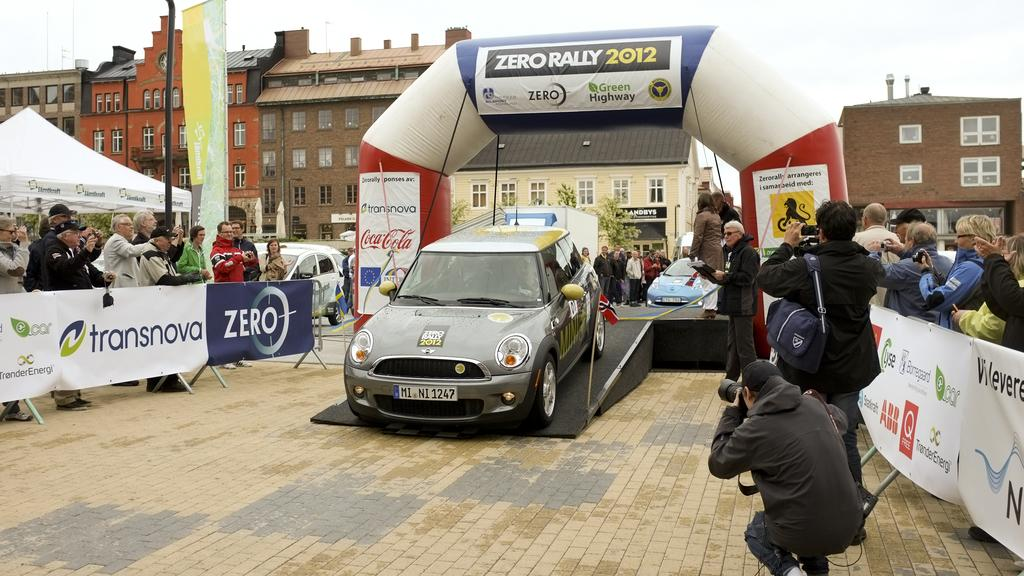What types of vehicles can be seen in the image? There are cars in the image. Can you describe the people in the image? There are people in the image. What kind of signage is present in the image? There are banners and hoardings in the image. What type of temporary shelter is visible in the image? There is a tent in the image. What is the tall, vertical structure in the image? There is a pole in the image. What type of vegetation is present in the image? There are trees in the image. What type of flat, rectangular objects are present in the image? There are boards in the image. What type of permanent structures are visible in the image? There are buildings in the image. What can be seen in the background of the image? The sky is visible in the background of the image. What type of bell can be heard ringing in the image? There is no bell present or audible in the image. How many legs are visible on the people in the image? The image does not show the legs of the people, so it cannot be determined from the image. 